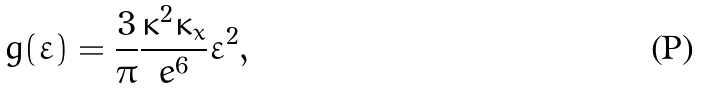Convert formula to latex. <formula><loc_0><loc_0><loc_500><loc_500>g ( \varepsilon ) = \frac { 3 } { \pi } \frac { \kappa ^ { 2 } \kappa _ { x } } { e ^ { 6 } } \varepsilon ^ { 2 } ,</formula> 